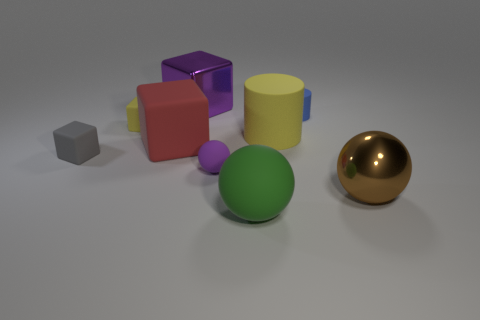Add 1 green spheres. How many objects exist? 10 Subtract all blocks. How many objects are left? 5 Add 5 tiny gray rubber objects. How many tiny gray rubber objects exist? 6 Subtract 1 green spheres. How many objects are left? 8 Subtract all large purple rubber cylinders. Subtract all spheres. How many objects are left? 6 Add 7 yellow blocks. How many yellow blocks are left? 8 